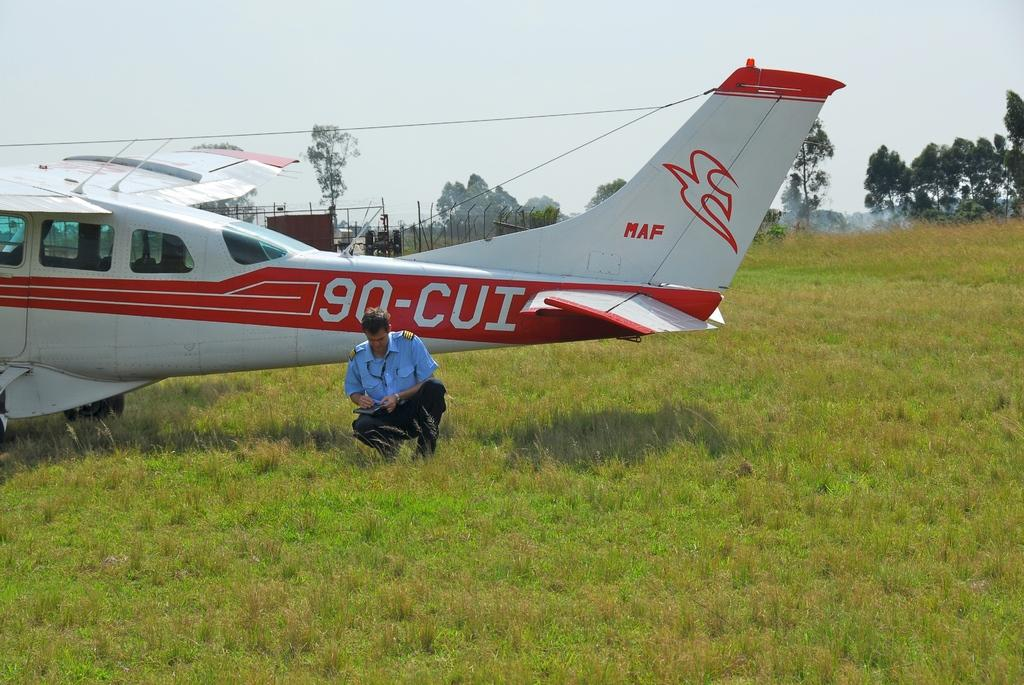Provide a one-sentence caption for the provided image. A man in a pilot uniform squatting in the grass next to the red and white small aircraft 90-CUI. 